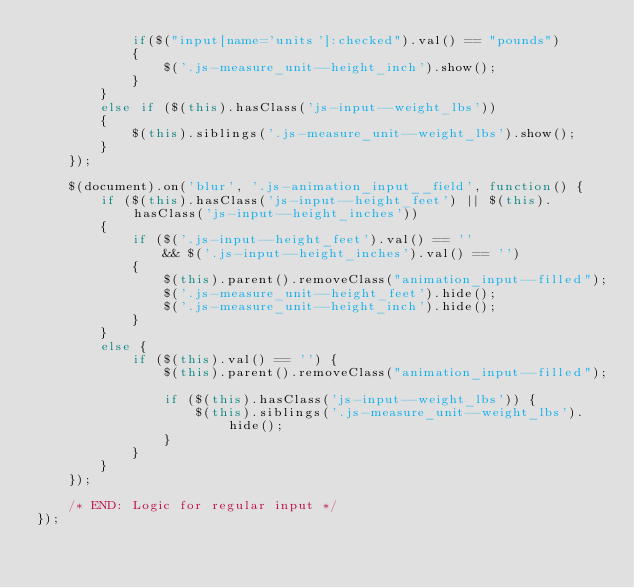<code> <loc_0><loc_0><loc_500><loc_500><_JavaScript_>			if($("input[name='units']:checked").val() == "pounds")
			{
				$('.js-measure_unit--height_inch').show();
			}
		}
		else if ($(this).hasClass('js-input--weight_lbs'))
		{
			$(this).siblings('.js-measure_unit--weight_lbs').show();
		}
	});

	$(document).on('blur', '.js-animation_input__field', function() {
		if ($(this).hasClass('js-input--height_feet') || $(this).hasClass('js-input--height_inches'))
		{
			if ($('.js-input--height_feet').val() == ''
				&& $('.js-input--height_inches').val() == '')
			{
				$(this).parent().removeClass("animation_input--filled");
				$('.js-measure_unit--height_feet').hide();
				$('.js-measure_unit--height_inch').hide();
			}
		}
		else {
			if ($(this).val() == '') {
				$(this).parent().removeClass("animation_input--filled");

				if ($(this).hasClass('js-input--weight_lbs')) {
					$(this).siblings('.js-measure_unit--weight_lbs').hide();
				}
			}
		}
	});

	/* END: Logic for regular input */
});
</code> 